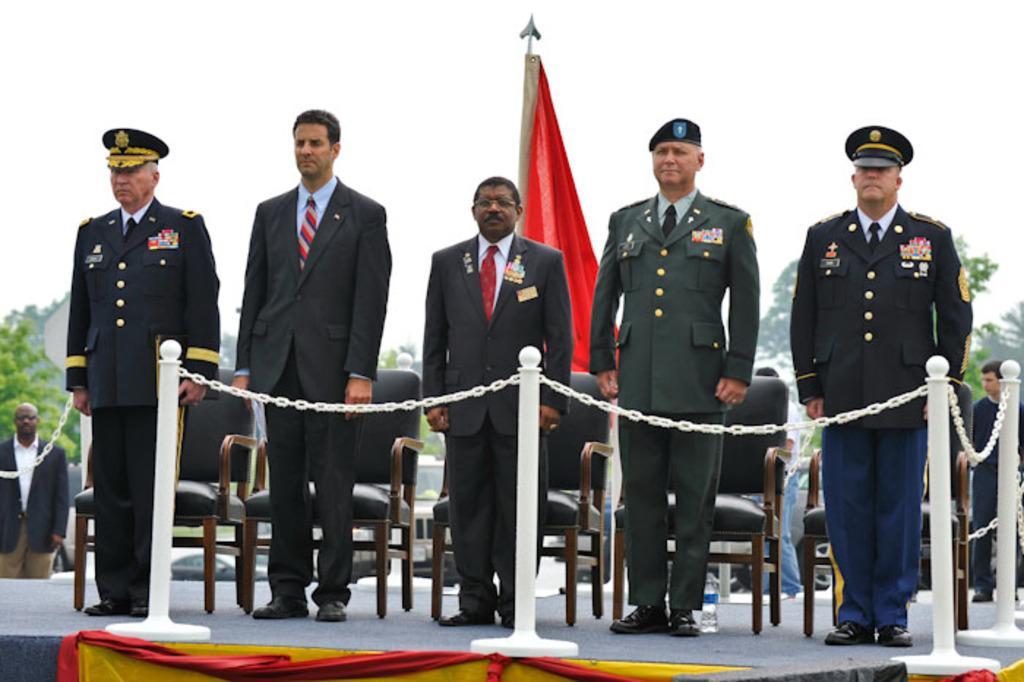Can you describe this image briefly? In this image we can see few people standing on the stage, there few rods with chains in front of them, there are few chairs, tress and the sky in the background. 